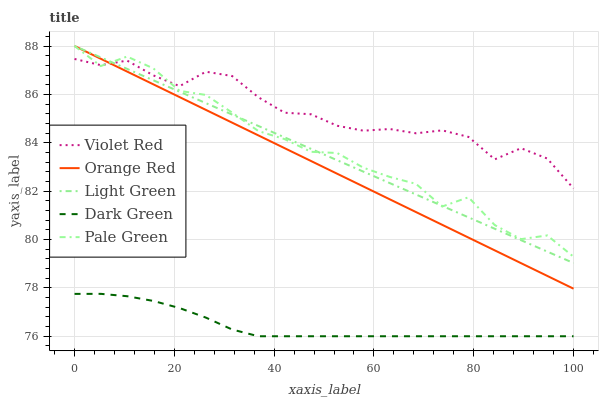Does Dark Green have the minimum area under the curve?
Answer yes or no. Yes. Does Violet Red have the maximum area under the curve?
Answer yes or no. Yes. Does Pale Green have the minimum area under the curve?
Answer yes or no. No. Does Pale Green have the maximum area under the curve?
Answer yes or no. No. Is Orange Red the smoothest?
Answer yes or no. Yes. Is Pale Green the roughest?
Answer yes or no. Yes. Is Pale Green the smoothest?
Answer yes or no. No. Is Orange Red the roughest?
Answer yes or no. No. Does Dark Green have the lowest value?
Answer yes or no. Yes. Does Pale Green have the lowest value?
Answer yes or no. No. Does Light Green have the highest value?
Answer yes or no. Yes. Does Dark Green have the highest value?
Answer yes or no. No. Is Dark Green less than Orange Red?
Answer yes or no. Yes. Is Pale Green greater than Dark Green?
Answer yes or no. Yes. Does Light Green intersect Pale Green?
Answer yes or no. Yes. Is Light Green less than Pale Green?
Answer yes or no. No. Is Light Green greater than Pale Green?
Answer yes or no. No. Does Dark Green intersect Orange Red?
Answer yes or no. No. 